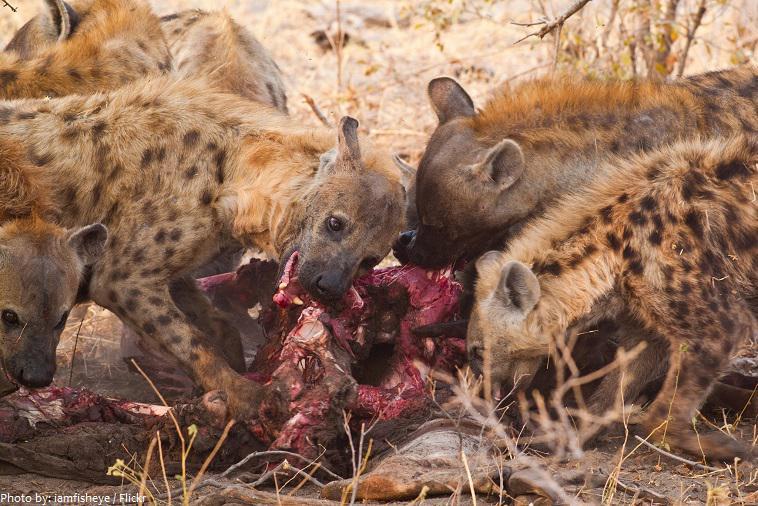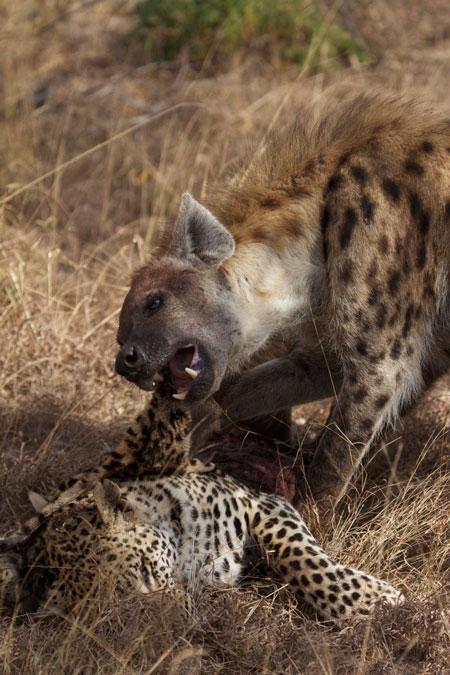The first image is the image on the left, the second image is the image on the right. Given the left and right images, does the statement "An image shows no more than two hyenas standing with the carcass of a leopard-type spotted cat." hold true? Answer yes or no. Yes. The first image is the image on the left, the second image is the image on the right. Evaluate the accuracy of this statement regarding the images: "There's no more than two hyenas in the left image.". Is it true? Answer yes or no. No. 